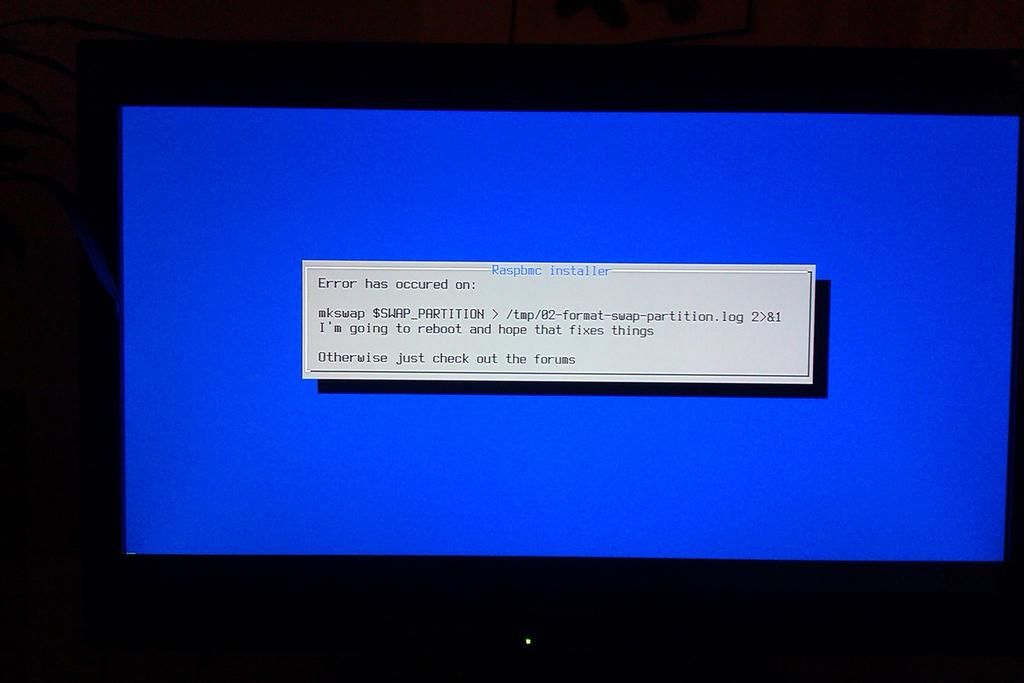Provide a one-sentence caption for the provided image. a blue screen on a computer bearing a message beginning with the word error. 